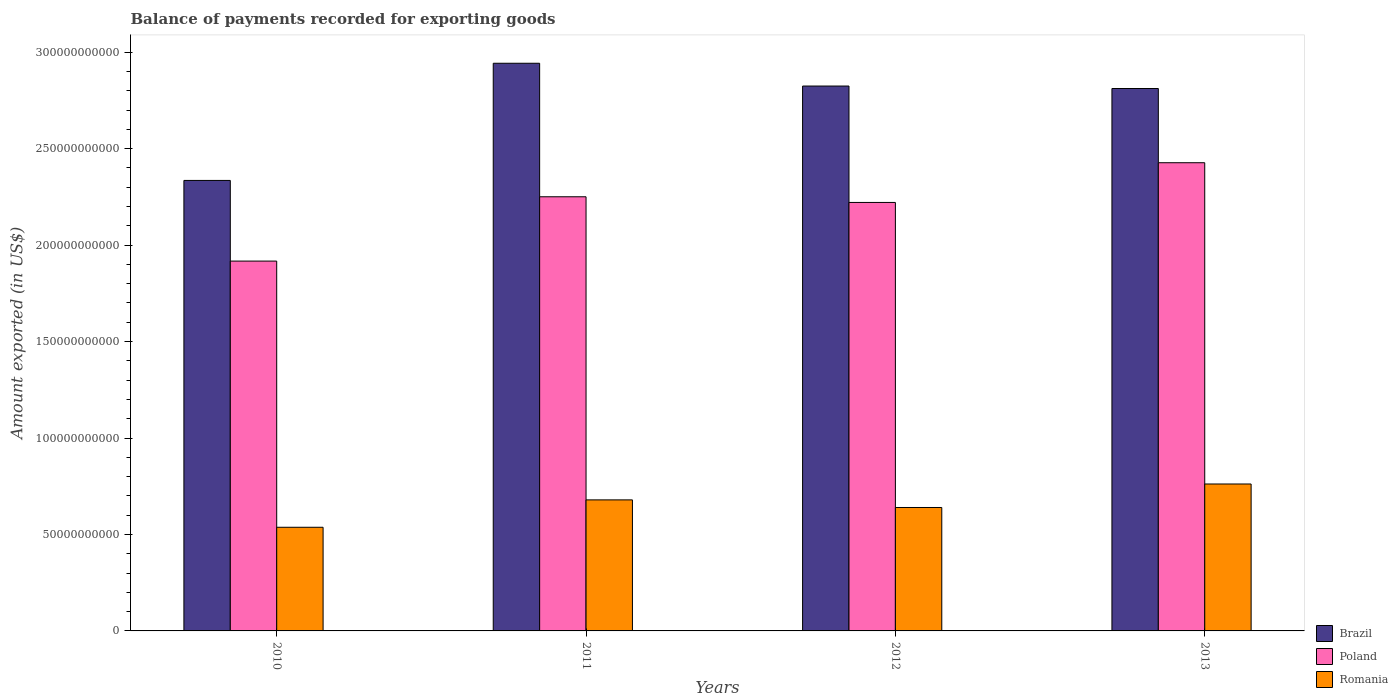How many different coloured bars are there?
Provide a succinct answer. 3. Are the number of bars per tick equal to the number of legend labels?
Give a very brief answer. Yes. Are the number of bars on each tick of the X-axis equal?
Keep it short and to the point. Yes. How many bars are there on the 3rd tick from the left?
Provide a succinct answer. 3. What is the label of the 3rd group of bars from the left?
Provide a succinct answer. 2012. What is the amount exported in Romania in 2010?
Offer a terse response. 5.37e+1. Across all years, what is the maximum amount exported in Romania?
Your answer should be compact. 7.62e+1. Across all years, what is the minimum amount exported in Poland?
Your answer should be very brief. 1.92e+11. In which year was the amount exported in Poland maximum?
Keep it short and to the point. 2013. What is the total amount exported in Brazil in the graph?
Provide a succinct answer. 1.09e+12. What is the difference between the amount exported in Brazil in 2011 and that in 2012?
Offer a very short reply. 1.18e+1. What is the difference between the amount exported in Brazil in 2011 and the amount exported in Poland in 2013?
Provide a succinct answer. 5.16e+1. What is the average amount exported in Romania per year?
Make the answer very short. 6.54e+1. In the year 2013, what is the difference between the amount exported in Brazil and amount exported in Romania?
Make the answer very short. 2.05e+11. In how many years, is the amount exported in Poland greater than 200000000000 US$?
Offer a very short reply. 3. What is the ratio of the amount exported in Brazil in 2011 to that in 2012?
Your answer should be very brief. 1.04. Is the amount exported in Poland in 2011 less than that in 2012?
Provide a short and direct response. No. What is the difference between the highest and the second highest amount exported in Poland?
Your answer should be very brief. 1.76e+1. What is the difference between the highest and the lowest amount exported in Poland?
Your response must be concise. 5.10e+1. What does the 3rd bar from the left in 2013 represents?
Ensure brevity in your answer.  Romania. Are all the bars in the graph horizontal?
Offer a very short reply. No. How many legend labels are there?
Provide a short and direct response. 3. What is the title of the graph?
Your answer should be compact. Balance of payments recorded for exporting goods. What is the label or title of the X-axis?
Make the answer very short. Years. What is the label or title of the Y-axis?
Your answer should be compact. Amount exported (in US$). What is the Amount exported (in US$) in Brazil in 2010?
Provide a short and direct response. 2.34e+11. What is the Amount exported (in US$) in Poland in 2010?
Your response must be concise. 1.92e+11. What is the Amount exported (in US$) in Romania in 2010?
Offer a terse response. 5.37e+1. What is the Amount exported (in US$) of Brazil in 2011?
Your answer should be very brief. 2.94e+11. What is the Amount exported (in US$) in Poland in 2011?
Make the answer very short. 2.25e+11. What is the Amount exported (in US$) of Romania in 2011?
Provide a short and direct response. 6.79e+1. What is the Amount exported (in US$) in Brazil in 2012?
Your response must be concise. 2.82e+11. What is the Amount exported (in US$) of Poland in 2012?
Keep it short and to the point. 2.22e+11. What is the Amount exported (in US$) in Romania in 2012?
Offer a terse response. 6.40e+1. What is the Amount exported (in US$) in Brazil in 2013?
Give a very brief answer. 2.81e+11. What is the Amount exported (in US$) of Poland in 2013?
Keep it short and to the point. 2.43e+11. What is the Amount exported (in US$) of Romania in 2013?
Give a very brief answer. 7.62e+1. Across all years, what is the maximum Amount exported (in US$) of Brazil?
Provide a succinct answer. 2.94e+11. Across all years, what is the maximum Amount exported (in US$) of Poland?
Your answer should be very brief. 2.43e+11. Across all years, what is the maximum Amount exported (in US$) of Romania?
Ensure brevity in your answer.  7.62e+1. Across all years, what is the minimum Amount exported (in US$) in Brazil?
Offer a terse response. 2.34e+11. Across all years, what is the minimum Amount exported (in US$) in Poland?
Offer a terse response. 1.92e+11. Across all years, what is the minimum Amount exported (in US$) of Romania?
Offer a very short reply. 5.37e+1. What is the total Amount exported (in US$) in Brazil in the graph?
Give a very brief answer. 1.09e+12. What is the total Amount exported (in US$) in Poland in the graph?
Offer a very short reply. 8.82e+11. What is the total Amount exported (in US$) of Romania in the graph?
Offer a terse response. 2.62e+11. What is the difference between the Amount exported (in US$) of Brazil in 2010 and that in 2011?
Provide a short and direct response. -6.07e+1. What is the difference between the Amount exported (in US$) in Poland in 2010 and that in 2011?
Your response must be concise. -3.33e+1. What is the difference between the Amount exported (in US$) in Romania in 2010 and that in 2011?
Provide a succinct answer. -1.42e+1. What is the difference between the Amount exported (in US$) in Brazil in 2010 and that in 2012?
Make the answer very short. -4.89e+1. What is the difference between the Amount exported (in US$) of Poland in 2010 and that in 2012?
Your answer should be very brief. -3.04e+1. What is the difference between the Amount exported (in US$) of Romania in 2010 and that in 2012?
Give a very brief answer. -1.02e+1. What is the difference between the Amount exported (in US$) in Brazil in 2010 and that in 2013?
Keep it short and to the point. -4.76e+1. What is the difference between the Amount exported (in US$) in Poland in 2010 and that in 2013?
Keep it short and to the point. -5.10e+1. What is the difference between the Amount exported (in US$) of Romania in 2010 and that in 2013?
Offer a terse response. -2.24e+1. What is the difference between the Amount exported (in US$) of Brazil in 2011 and that in 2012?
Ensure brevity in your answer.  1.18e+1. What is the difference between the Amount exported (in US$) of Poland in 2011 and that in 2012?
Make the answer very short. 2.94e+09. What is the difference between the Amount exported (in US$) in Romania in 2011 and that in 2012?
Keep it short and to the point. 3.95e+09. What is the difference between the Amount exported (in US$) in Brazil in 2011 and that in 2013?
Provide a succinct answer. 1.31e+1. What is the difference between the Amount exported (in US$) in Poland in 2011 and that in 2013?
Give a very brief answer. -1.76e+1. What is the difference between the Amount exported (in US$) of Romania in 2011 and that in 2013?
Give a very brief answer. -8.24e+09. What is the difference between the Amount exported (in US$) of Brazil in 2012 and that in 2013?
Ensure brevity in your answer.  1.28e+09. What is the difference between the Amount exported (in US$) in Poland in 2012 and that in 2013?
Your answer should be compact. -2.06e+1. What is the difference between the Amount exported (in US$) in Romania in 2012 and that in 2013?
Provide a short and direct response. -1.22e+1. What is the difference between the Amount exported (in US$) of Brazil in 2010 and the Amount exported (in US$) of Poland in 2011?
Your answer should be very brief. 8.47e+09. What is the difference between the Amount exported (in US$) of Brazil in 2010 and the Amount exported (in US$) of Romania in 2011?
Your response must be concise. 1.66e+11. What is the difference between the Amount exported (in US$) in Poland in 2010 and the Amount exported (in US$) in Romania in 2011?
Give a very brief answer. 1.24e+11. What is the difference between the Amount exported (in US$) in Brazil in 2010 and the Amount exported (in US$) in Poland in 2012?
Offer a terse response. 1.14e+1. What is the difference between the Amount exported (in US$) of Brazil in 2010 and the Amount exported (in US$) of Romania in 2012?
Make the answer very short. 1.70e+11. What is the difference between the Amount exported (in US$) of Poland in 2010 and the Amount exported (in US$) of Romania in 2012?
Keep it short and to the point. 1.28e+11. What is the difference between the Amount exported (in US$) in Brazil in 2010 and the Amount exported (in US$) in Poland in 2013?
Offer a very short reply. -9.17e+09. What is the difference between the Amount exported (in US$) of Brazil in 2010 and the Amount exported (in US$) of Romania in 2013?
Offer a terse response. 1.57e+11. What is the difference between the Amount exported (in US$) of Poland in 2010 and the Amount exported (in US$) of Romania in 2013?
Offer a very short reply. 1.16e+11. What is the difference between the Amount exported (in US$) in Brazil in 2011 and the Amount exported (in US$) in Poland in 2012?
Your answer should be very brief. 7.22e+1. What is the difference between the Amount exported (in US$) in Brazil in 2011 and the Amount exported (in US$) in Romania in 2012?
Keep it short and to the point. 2.30e+11. What is the difference between the Amount exported (in US$) of Poland in 2011 and the Amount exported (in US$) of Romania in 2012?
Make the answer very short. 1.61e+11. What is the difference between the Amount exported (in US$) of Brazil in 2011 and the Amount exported (in US$) of Poland in 2013?
Your answer should be compact. 5.16e+1. What is the difference between the Amount exported (in US$) in Brazil in 2011 and the Amount exported (in US$) in Romania in 2013?
Your response must be concise. 2.18e+11. What is the difference between the Amount exported (in US$) in Poland in 2011 and the Amount exported (in US$) in Romania in 2013?
Ensure brevity in your answer.  1.49e+11. What is the difference between the Amount exported (in US$) in Brazil in 2012 and the Amount exported (in US$) in Poland in 2013?
Provide a short and direct response. 3.98e+1. What is the difference between the Amount exported (in US$) in Brazil in 2012 and the Amount exported (in US$) in Romania in 2013?
Your answer should be very brief. 2.06e+11. What is the difference between the Amount exported (in US$) of Poland in 2012 and the Amount exported (in US$) of Romania in 2013?
Ensure brevity in your answer.  1.46e+11. What is the average Amount exported (in US$) of Brazil per year?
Offer a very short reply. 2.73e+11. What is the average Amount exported (in US$) of Poland per year?
Ensure brevity in your answer.  2.20e+11. What is the average Amount exported (in US$) in Romania per year?
Offer a very short reply. 6.54e+1. In the year 2010, what is the difference between the Amount exported (in US$) in Brazil and Amount exported (in US$) in Poland?
Offer a very short reply. 4.18e+1. In the year 2010, what is the difference between the Amount exported (in US$) in Brazil and Amount exported (in US$) in Romania?
Provide a short and direct response. 1.80e+11. In the year 2010, what is the difference between the Amount exported (in US$) of Poland and Amount exported (in US$) of Romania?
Keep it short and to the point. 1.38e+11. In the year 2011, what is the difference between the Amount exported (in US$) in Brazil and Amount exported (in US$) in Poland?
Offer a terse response. 6.92e+1. In the year 2011, what is the difference between the Amount exported (in US$) in Brazil and Amount exported (in US$) in Romania?
Keep it short and to the point. 2.26e+11. In the year 2011, what is the difference between the Amount exported (in US$) of Poland and Amount exported (in US$) of Romania?
Your answer should be compact. 1.57e+11. In the year 2012, what is the difference between the Amount exported (in US$) in Brazil and Amount exported (in US$) in Poland?
Offer a terse response. 6.03e+1. In the year 2012, what is the difference between the Amount exported (in US$) of Brazil and Amount exported (in US$) of Romania?
Your answer should be compact. 2.18e+11. In the year 2012, what is the difference between the Amount exported (in US$) of Poland and Amount exported (in US$) of Romania?
Your response must be concise. 1.58e+11. In the year 2013, what is the difference between the Amount exported (in US$) of Brazil and Amount exported (in US$) of Poland?
Offer a terse response. 3.85e+1. In the year 2013, what is the difference between the Amount exported (in US$) of Brazil and Amount exported (in US$) of Romania?
Make the answer very short. 2.05e+11. In the year 2013, what is the difference between the Amount exported (in US$) in Poland and Amount exported (in US$) in Romania?
Give a very brief answer. 1.67e+11. What is the ratio of the Amount exported (in US$) of Brazil in 2010 to that in 2011?
Your response must be concise. 0.79. What is the ratio of the Amount exported (in US$) of Poland in 2010 to that in 2011?
Make the answer very short. 0.85. What is the ratio of the Amount exported (in US$) in Romania in 2010 to that in 2011?
Offer a terse response. 0.79. What is the ratio of the Amount exported (in US$) in Brazil in 2010 to that in 2012?
Offer a terse response. 0.83. What is the ratio of the Amount exported (in US$) of Poland in 2010 to that in 2012?
Ensure brevity in your answer.  0.86. What is the ratio of the Amount exported (in US$) of Romania in 2010 to that in 2012?
Provide a short and direct response. 0.84. What is the ratio of the Amount exported (in US$) of Brazil in 2010 to that in 2013?
Your answer should be compact. 0.83. What is the ratio of the Amount exported (in US$) of Poland in 2010 to that in 2013?
Make the answer very short. 0.79. What is the ratio of the Amount exported (in US$) of Romania in 2010 to that in 2013?
Offer a terse response. 0.71. What is the ratio of the Amount exported (in US$) of Brazil in 2011 to that in 2012?
Your answer should be very brief. 1.04. What is the ratio of the Amount exported (in US$) of Poland in 2011 to that in 2012?
Keep it short and to the point. 1.01. What is the ratio of the Amount exported (in US$) in Romania in 2011 to that in 2012?
Your answer should be compact. 1.06. What is the ratio of the Amount exported (in US$) in Brazil in 2011 to that in 2013?
Your response must be concise. 1.05. What is the ratio of the Amount exported (in US$) in Poland in 2011 to that in 2013?
Ensure brevity in your answer.  0.93. What is the ratio of the Amount exported (in US$) of Romania in 2011 to that in 2013?
Your answer should be very brief. 0.89. What is the ratio of the Amount exported (in US$) in Poland in 2012 to that in 2013?
Ensure brevity in your answer.  0.92. What is the ratio of the Amount exported (in US$) of Romania in 2012 to that in 2013?
Provide a short and direct response. 0.84. What is the difference between the highest and the second highest Amount exported (in US$) in Brazil?
Your answer should be very brief. 1.18e+1. What is the difference between the highest and the second highest Amount exported (in US$) of Poland?
Your response must be concise. 1.76e+1. What is the difference between the highest and the second highest Amount exported (in US$) of Romania?
Give a very brief answer. 8.24e+09. What is the difference between the highest and the lowest Amount exported (in US$) in Brazil?
Your response must be concise. 6.07e+1. What is the difference between the highest and the lowest Amount exported (in US$) of Poland?
Give a very brief answer. 5.10e+1. What is the difference between the highest and the lowest Amount exported (in US$) in Romania?
Your answer should be very brief. 2.24e+1. 